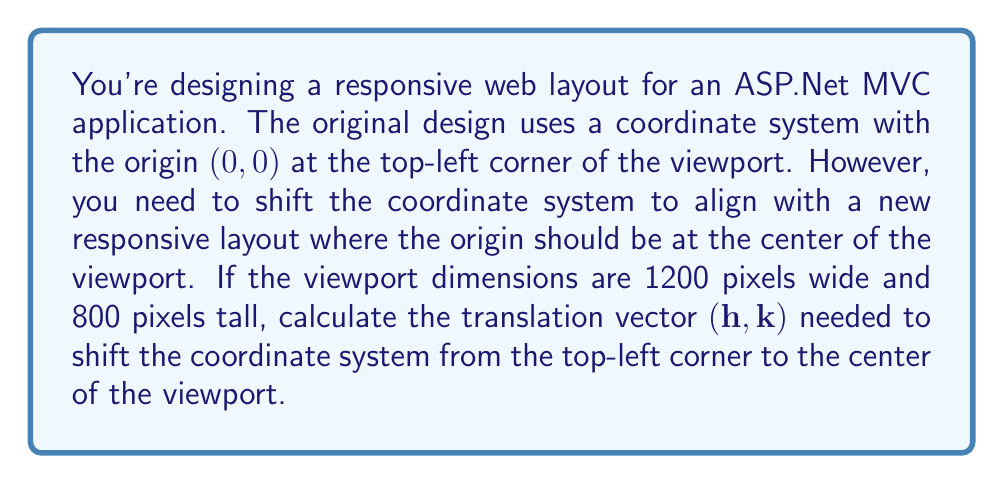Solve this math problem. To solve this problem, we need to determine how much to shift the coordinate system horizontally and vertically to move the origin from the top-left corner to the center of the viewport. Let's break it down step-by-step:

1. Horizontal shift (h):
   - The viewport width is 1200 pixels.
   - To move the origin to the center horizontally, we need to shift it by half the width.
   - $h = \frac{1200}{2} = 600$ pixels

2. Vertical shift (k):
   - The viewport height is 800 pixels.
   - To move the origin to the center vertically, we need to shift it by half the height.
   - $k = \frac{800}{2} = 400$ pixels

3. Translation vector:
   - The translation vector is represented as $(h, k)$, where h is the horizontal shift and k is the vertical shift.
   - In this case, the translation vector is $(600, 400)$

Note that in a typical coordinate system, moving right and up are considered positive directions. However, in many computer graphics systems (including web layouts), the y-axis is inverted, with positive y pointing downward. Therefore, we use a positive value for k to shift the origin downward.

The translation transformation can be represented mathematically as:

$$(x', y') = (x + h, y + k)$$

where $(x, y)$ is a point in the original coordinate system, and $(x', y')$ is the corresponding point in the translated coordinate system.
Answer: The translation vector needed to shift the coordinate system from the top-left corner to the center of the viewport is $(600, 400)$. 